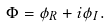Convert formula to latex. <formula><loc_0><loc_0><loc_500><loc_500>\Phi = \phi _ { R } + i \phi _ { I } .</formula> 